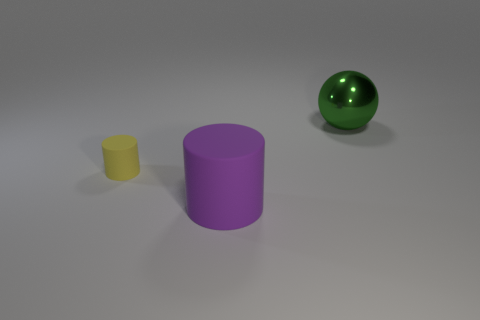Are there more tiny yellow matte cylinders that are behind the yellow matte thing than cyan things?
Provide a short and direct response. No. There is a matte thing that is in front of the yellow object; does it have the same size as the green metal ball?
Ensure brevity in your answer.  Yes. Is there a yellow cylinder of the same size as the green metal sphere?
Provide a short and direct response. No. There is a large thing that is behind the large matte thing; what color is it?
Provide a short and direct response. Green. What is the shape of the thing that is behind the big purple rubber cylinder and on the right side of the small cylinder?
Give a very brief answer. Sphere. How many other green objects have the same shape as the tiny object?
Ensure brevity in your answer.  0. How many large red cylinders are there?
Make the answer very short. 0. What size is the object that is in front of the metallic thing and to the right of the small cylinder?
Provide a short and direct response. Large. What is the shape of the thing that is the same size as the purple cylinder?
Provide a short and direct response. Sphere. There is a rubber cylinder behind the big purple rubber cylinder; is there a green metal object in front of it?
Provide a succinct answer. No. 